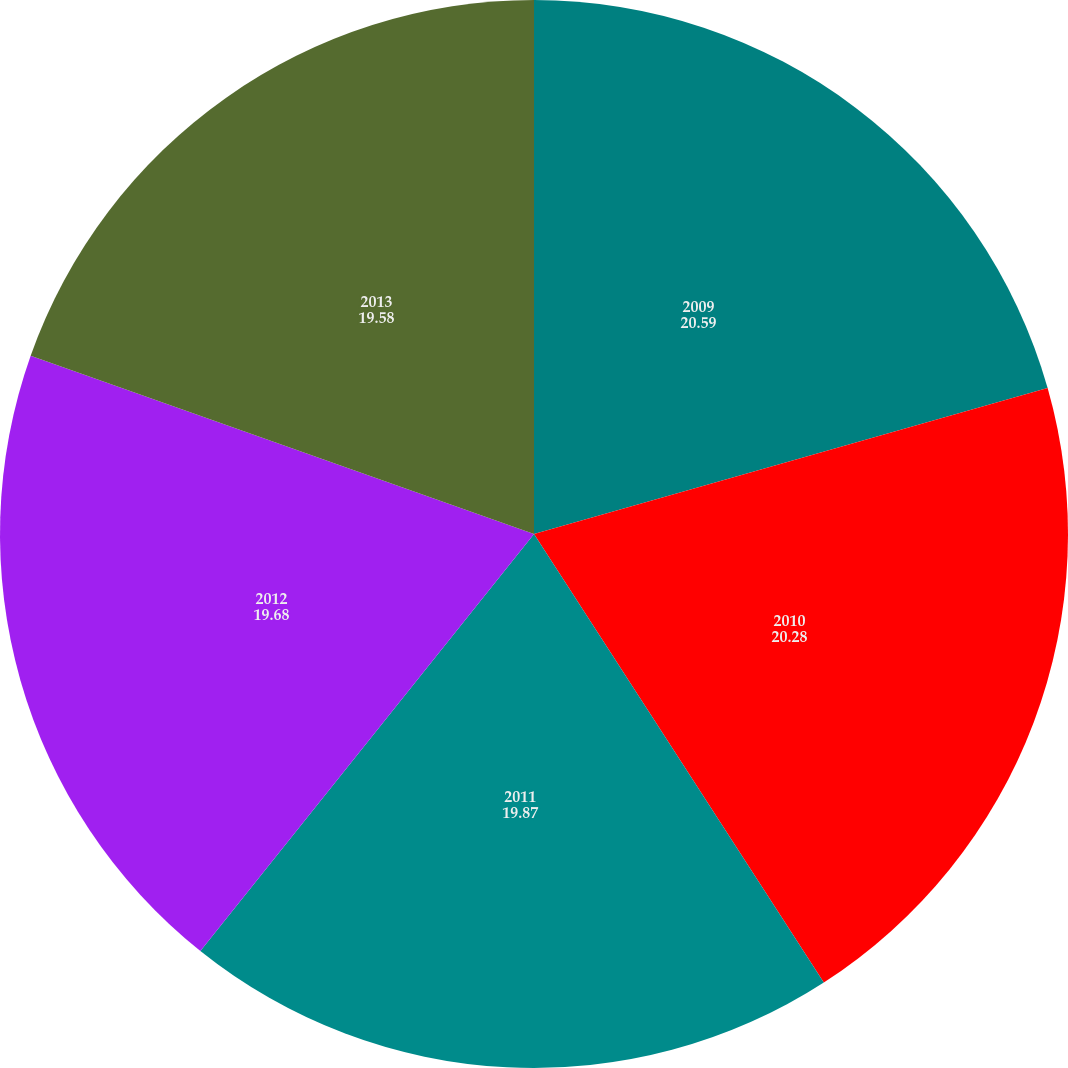<chart> <loc_0><loc_0><loc_500><loc_500><pie_chart><fcel>2009<fcel>2010<fcel>2011<fcel>2012<fcel>2013<nl><fcel>20.59%<fcel>20.28%<fcel>19.87%<fcel>19.68%<fcel>19.58%<nl></chart> 